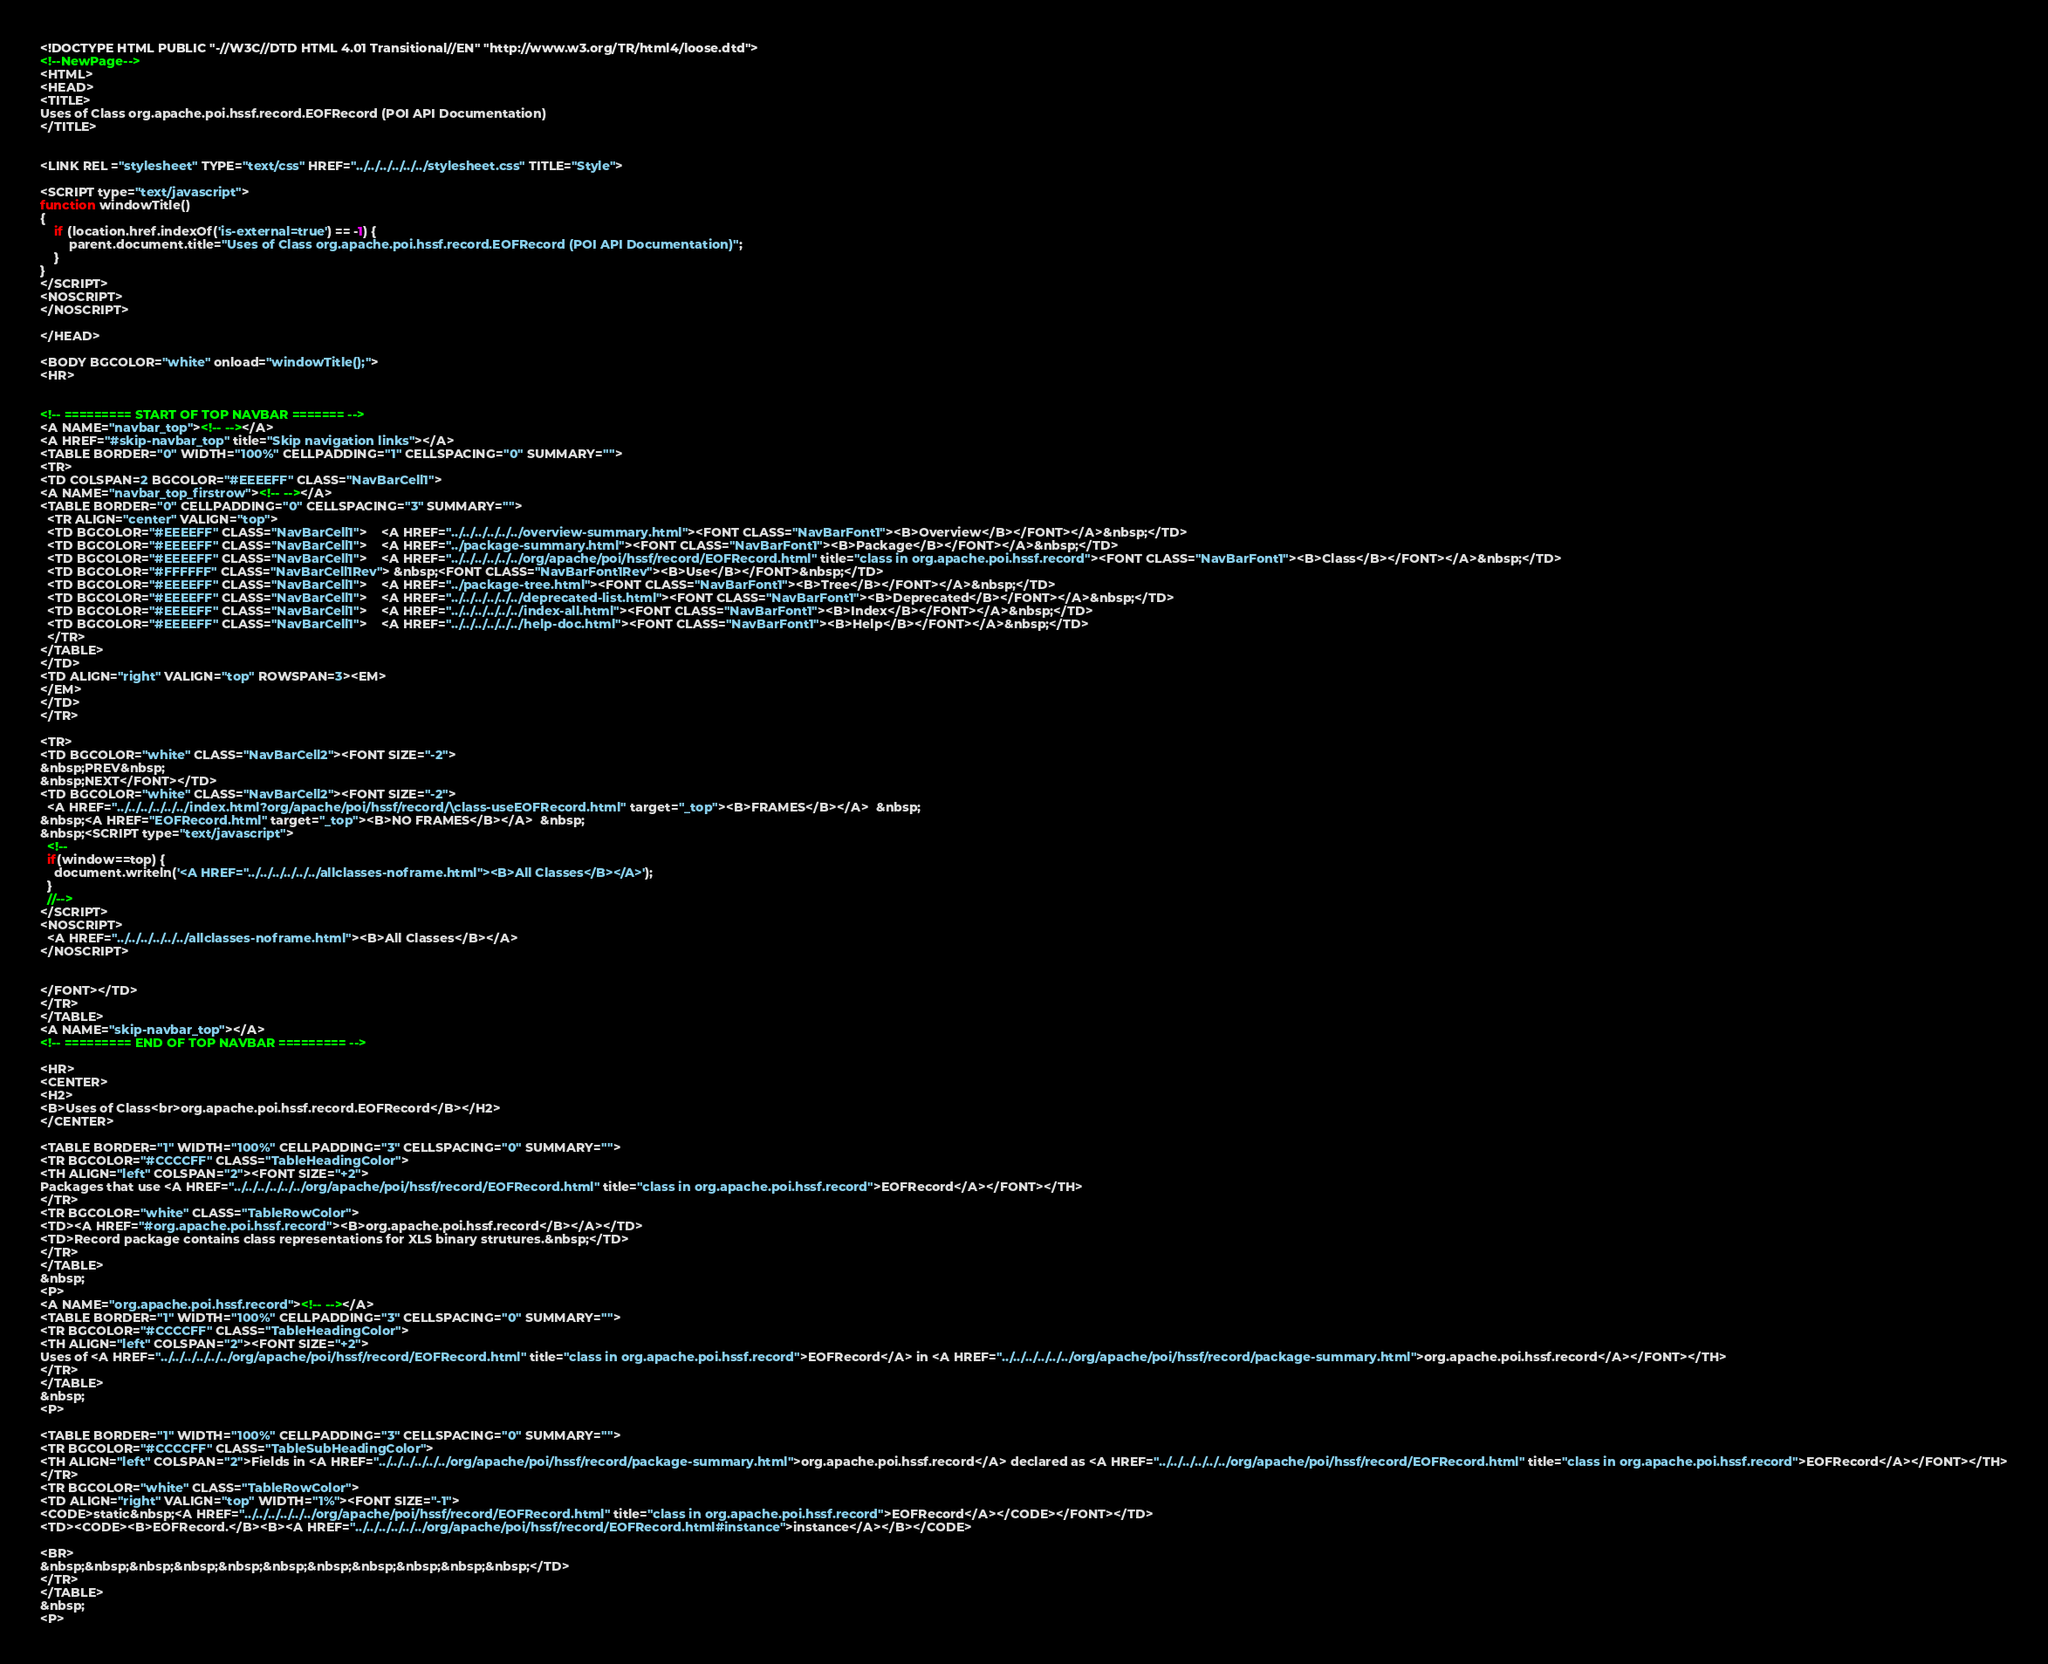<code> <loc_0><loc_0><loc_500><loc_500><_HTML_><!DOCTYPE HTML PUBLIC "-//W3C//DTD HTML 4.01 Transitional//EN" "http://www.w3.org/TR/html4/loose.dtd">
<!--NewPage-->
<HTML>
<HEAD>
<TITLE>
Uses of Class org.apache.poi.hssf.record.EOFRecord (POI API Documentation)
</TITLE>


<LINK REL ="stylesheet" TYPE="text/css" HREF="../../../../../../stylesheet.css" TITLE="Style">

<SCRIPT type="text/javascript">
function windowTitle()
{
    if (location.href.indexOf('is-external=true') == -1) {
        parent.document.title="Uses of Class org.apache.poi.hssf.record.EOFRecord (POI API Documentation)";
    }
}
</SCRIPT>
<NOSCRIPT>
</NOSCRIPT>

</HEAD>

<BODY BGCOLOR="white" onload="windowTitle();">
<HR>


<!-- ========= START OF TOP NAVBAR ======= -->
<A NAME="navbar_top"><!-- --></A>
<A HREF="#skip-navbar_top" title="Skip navigation links"></A>
<TABLE BORDER="0" WIDTH="100%" CELLPADDING="1" CELLSPACING="0" SUMMARY="">
<TR>
<TD COLSPAN=2 BGCOLOR="#EEEEFF" CLASS="NavBarCell1">
<A NAME="navbar_top_firstrow"><!-- --></A>
<TABLE BORDER="0" CELLPADDING="0" CELLSPACING="3" SUMMARY="">
  <TR ALIGN="center" VALIGN="top">
  <TD BGCOLOR="#EEEEFF" CLASS="NavBarCell1">    <A HREF="../../../../../../overview-summary.html"><FONT CLASS="NavBarFont1"><B>Overview</B></FONT></A>&nbsp;</TD>
  <TD BGCOLOR="#EEEEFF" CLASS="NavBarCell1">    <A HREF="../package-summary.html"><FONT CLASS="NavBarFont1"><B>Package</B></FONT></A>&nbsp;</TD>
  <TD BGCOLOR="#EEEEFF" CLASS="NavBarCell1">    <A HREF="../../../../../../org/apache/poi/hssf/record/EOFRecord.html" title="class in org.apache.poi.hssf.record"><FONT CLASS="NavBarFont1"><B>Class</B></FONT></A>&nbsp;</TD>
  <TD BGCOLOR="#FFFFFF" CLASS="NavBarCell1Rev"> &nbsp;<FONT CLASS="NavBarFont1Rev"><B>Use</B></FONT>&nbsp;</TD>
  <TD BGCOLOR="#EEEEFF" CLASS="NavBarCell1">    <A HREF="../package-tree.html"><FONT CLASS="NavBarFont1"><B>Tree</B></FONT></A>&nbsp;</TD>
  <TD BGCOLOR="#EEEEFF" CLASS="NavBarCell1">    <A HREF="../../../../../../deprecated-list.html"><FONT CLASS="NavBarFont1"><B>Deprecated</B></FONT></A>&nbsp;</TD>
  <TD BGCOLOR="#EEEEFF" CLASS="NavBarCell1">    <A HREF="../../../../../../index-all.html"><FONT CLASS="NavBarFont1"><B>Index</B></FONT></A>&nbsp;</TD>
  <TD BGCOLOR="#EEEEFF" CLASS="NavBarCell1">    <A HREF="../../../../../../help-doc.html"><FONT CLASS="NavBarFont1"><B>Help</B></FONT></A>&nbsp;</TD>
  </TR>
</TABLE>
</TD>
<TD ALIGN="right" VALIGN="top" ROWSPAN=3><EM>
</EM>
</TD>
</TR>

<TR>
<TD BGCOLOR="white" CLASS="NavBarCell2"><FONT SIZE="-2">
&nbsp;PREV&nbsp;
&nbsp;NEXT</FONT></TD>
<TD BGCOLOR="white" CLASS="NavBarCell2"><FONT SIZE="-2">
  <A HREF="../../../../../../index.html?org/apache/poi/hssf/record/\class-useEOFRecord.html" target="_top"><B>FRAMES</B></A>  &nbsp;
&nbsp;<A HREF="EOFRecord.html" target="_top"><B>NO FRAMES</B></A>  &nbsp;
&nbsp;<SCRIPT type="text/javascript">
  <!--
  if(window==top) {
    document.writeln('<A HREF="../../../../../../allclasses-noframe.html"><B>All Classes</B></A>');
  }
  //-->
</SCRIPT>
<NOSCRIPT>
  <A HREF="../../../../../../allclasses-noframe.html"><B>All Classes</B></A>
</NOSCRIPT>


</FONT></TD>
</TR>
</TABLE>
<A NAME="skip-navbar_top"></A>
<!-- ========= END OF TOP NAVBAR ========= -->

<HR>
<CENTER>
<H2>
<B>Uses of Class<br>org.apache.poi.hssf.record.EOFRecord</B></H2>
</CENTER>

<TABLE BORDER="1" WIDTH="100%" CELLPADDING="3" CELLSPACING="0" SUMMARY="">
<TR BGCOLOR="#CCCCFF" CLASS="TableHeadingColor">
<TH ALIGN="left" COLSPAN="2"><FONT SIZE="+2">
Packages that use <A HREF="../../../../../../org/apache/poi/hssf/record/EOFRecord.html" title="class in org.apache.poi.hssf.record">EOFRecord</A></FONT></TH>
</TR>
<TR BGCOLOR="white" CLASS="TableRowColor">
<TD><A HREF="#org.apache.poi.hssf.record"><B>org.apache.poi.hssf.record</B></A></TD>
<TD>Record package contains class representations for XLS binary strutures.&nbsp;</TD>
</TR>
</TABLE>
&nbsp;
<P>
<A NAME="org.apache.poi.hssf.record"><!-- --></A>
<TABLE BORDER="1" WIDTH="100%" CELLPADDING="3" CELLSPACING="0" SUMMARY="">
<TR BGCOLOR="#CCCCFF" CLASS="TableHeadingColor">
<TH ALIGN="left" COLSPAN="2"><FONT SIZE="+2">
Uses of <A HREF="../../../../../../org/apache/poi/hssf/record/EOFRecord.html" title="class in org.apache.poi.hssf.record">EOFRecord</A> in <A HREF="../../../../../../org/apache/poi/hssf/record/package-summary.html">org.apache.poi.hssf.record</A></FONT></TH>
</TR>
</TABLE>
&nbsp;
<P>

<TABLE BORDER="1" WIDTH="100%" CELLPADDING="3" CELLSPACING="0" SUMMARY="">
<TR BGCOLOR="#CCCCFF" CLASS="TableSubHeadingColor">
<TH ALIGN="left" COLSPAN="2">Fields in <A HREF="../../../../../../org/apache/poi/hssf/record/package-summary.html">org.apache.poi.hssf.record</A> declared as <A HREF="../../../../../../org/apache/poi/hssf/record/EOFRecord.html" title="class in org.apache.poi.hssf.record">EOFRecord</A></FONT></TH>
</TR>
<TR BGCOLOR="white" CLASS="TableRowColor">
<TD ALIGN="right" VALIGN="top" WIDTH="1%"><FONT SIZE="-1">
<CODE>static&nbsp;<A HREF="../../../../../../org/apache/poi/hssf/record/EOFRecord.html" title="class in org.apache.poi.hssf.record">EOFRecord</A></CODE></FONT></TD>
<TD><CODE><B>EOFRecord.</B><B><A HREF="../../../../../../org/apache/poi/hssf/record/EOFRecord.html#instance">instance</A></B></CODE>

<BR>
&nbsp;&nbsp;&nbsp;&nbsp;&nbsp;&nbsp;&nbsp;&nbsp;&nbsp;&nbsp;&nbsp;</TD>
</TR>
</TABLE>
&nbsp;
<P>
</code> 